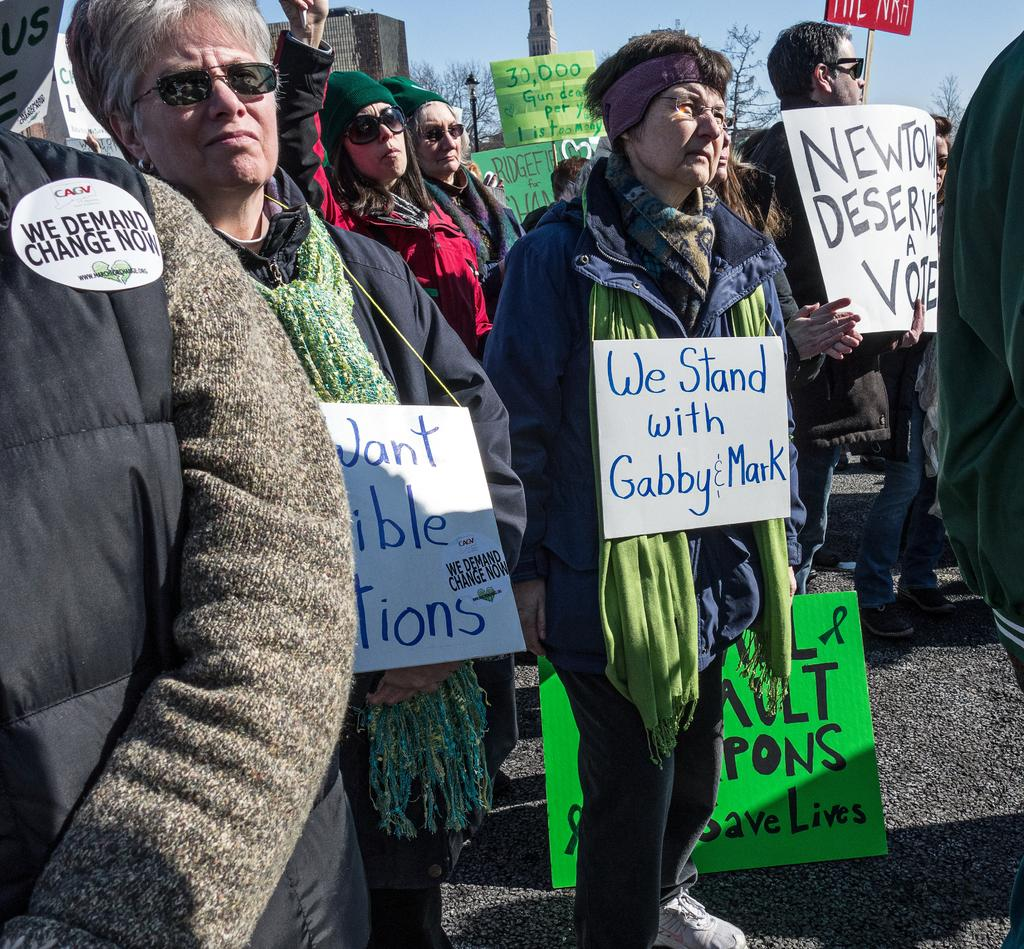What are the persons in the image doing? The persons in the image are standing on the ground and holding boards in their hands. What can be seen in the background of the image? There are trees and the sky visible in the background of the image. What type of celery can be seen growing in the image? There is no celery present in the image. What color is the hair of the person on the left in the image? There is no indication of hair color for any person in the image, as their heads are not visible. 